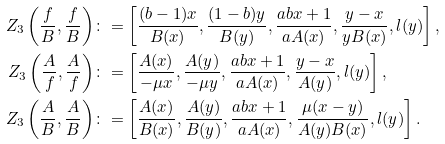Convert formula to latex. <formula><loc_0><loc_0><loc_500><loc_500>Z _ { 3 } \left ( \frac { f } { B } , \frac { f } { B } \right ) & \colon = \left [ \frac { ( b - 1 ) x } { B ( x ) } , \frac { ( 1 - b ) y } { B ( y ) } , \frac { a b x + 1 } { a A ( x ) } , \frac { y - x } { y B ( x ) } , l ( y ) \right ] , \\ Z _ { 3 } \left ( \frac { A } { f } , \frac { A } { f } \right ) & \colon = \left [ \frac { A ( x ) } { - \mu x } , \frac { A ( y ) } { - \mu y } , \frac { a b x + 1 } { a A ( x ) } , \frac { y - x } { A ( y ) } , l ( y ) \right ] , \\ Z _ { 3 } \left ( \frac { A } { B } , \frac { A } { B } \right ) & \colon = \left [ \frac { A ( x ) } { B ( x ) } , \frac { A ( y ) } { B ( y ) } , \frac { a b x + 1 } { a A ( x ) } , \frac { \mu ( x - y ) } { A ( y ) B ( x ) } , l ( y ) \right ] .</formula> 